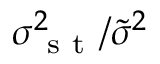<formula> <loc_0><loc_0><loc_500><loc_500>\sigma _ { s t } ^ { 2 } / \widetilde { \sigma } ^ { 2 }</formula> 